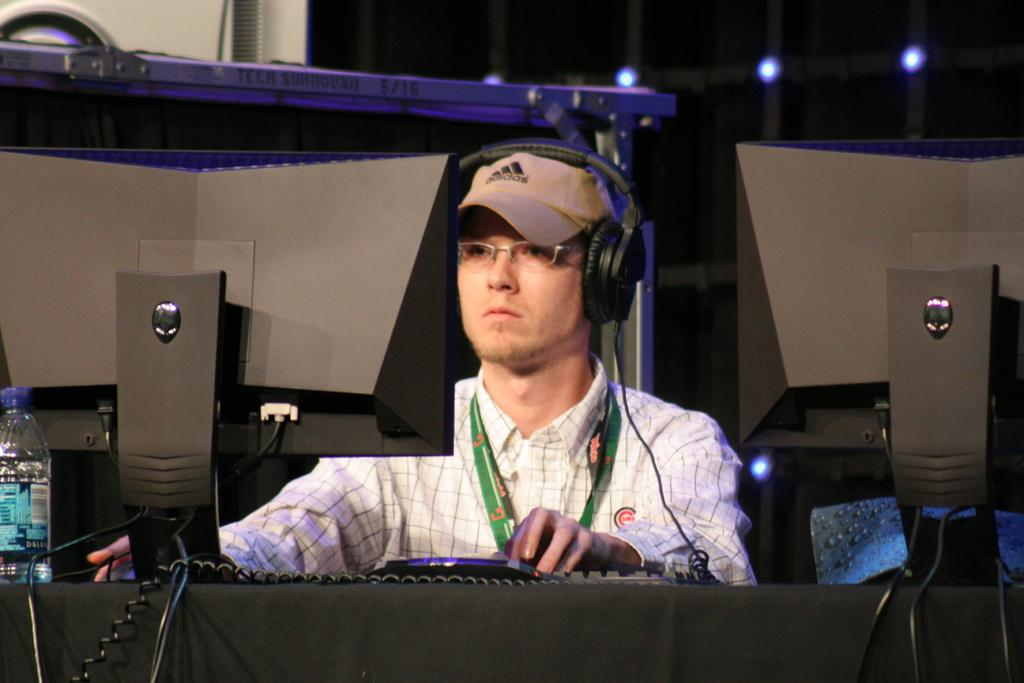Who is present in the image? There is a man in the image. What is the man doing in the image? The man is sitting. What is in front of the man? There is an object in front of the man. What is the man wearing on his ears? The man is wearing headphones. What type of fear can be seen on the man's face in the image? There is no fear visible on the man's face in the image. What is the man eating from in the image? There is no plate or food present in the image, so it cannot be determined what the man might be eating from. 